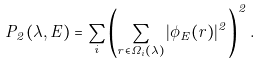<formula> <loc_0><loc_0><loc_500><loc_500>P _ { 2 } ( \lambda , E ) = \sum _ { i } \left ( \sum _ { { r } \in \Omega _ { i } ( \lambda ) } | \phi _ { E } ( { r } ) | ^ { 2 } \right ) ^ { 2 } .</formula> 